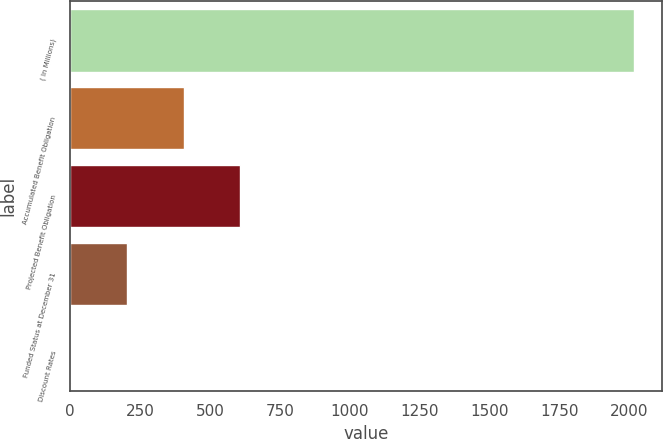<chart> <loc_0><loc_0><loc_500><loc_500><bar_chart><fcel>( In Millions)<fcel>Accumulated Benefit Obligation<fcel>Projected Benefit Obligation<fcel>Funded Status at December 31<fcel>Discount Rates<nl><fcel>2015<fcel>405.71<fcel>606.87<fcel>204.55<fcel>3.39<nl></chart> 